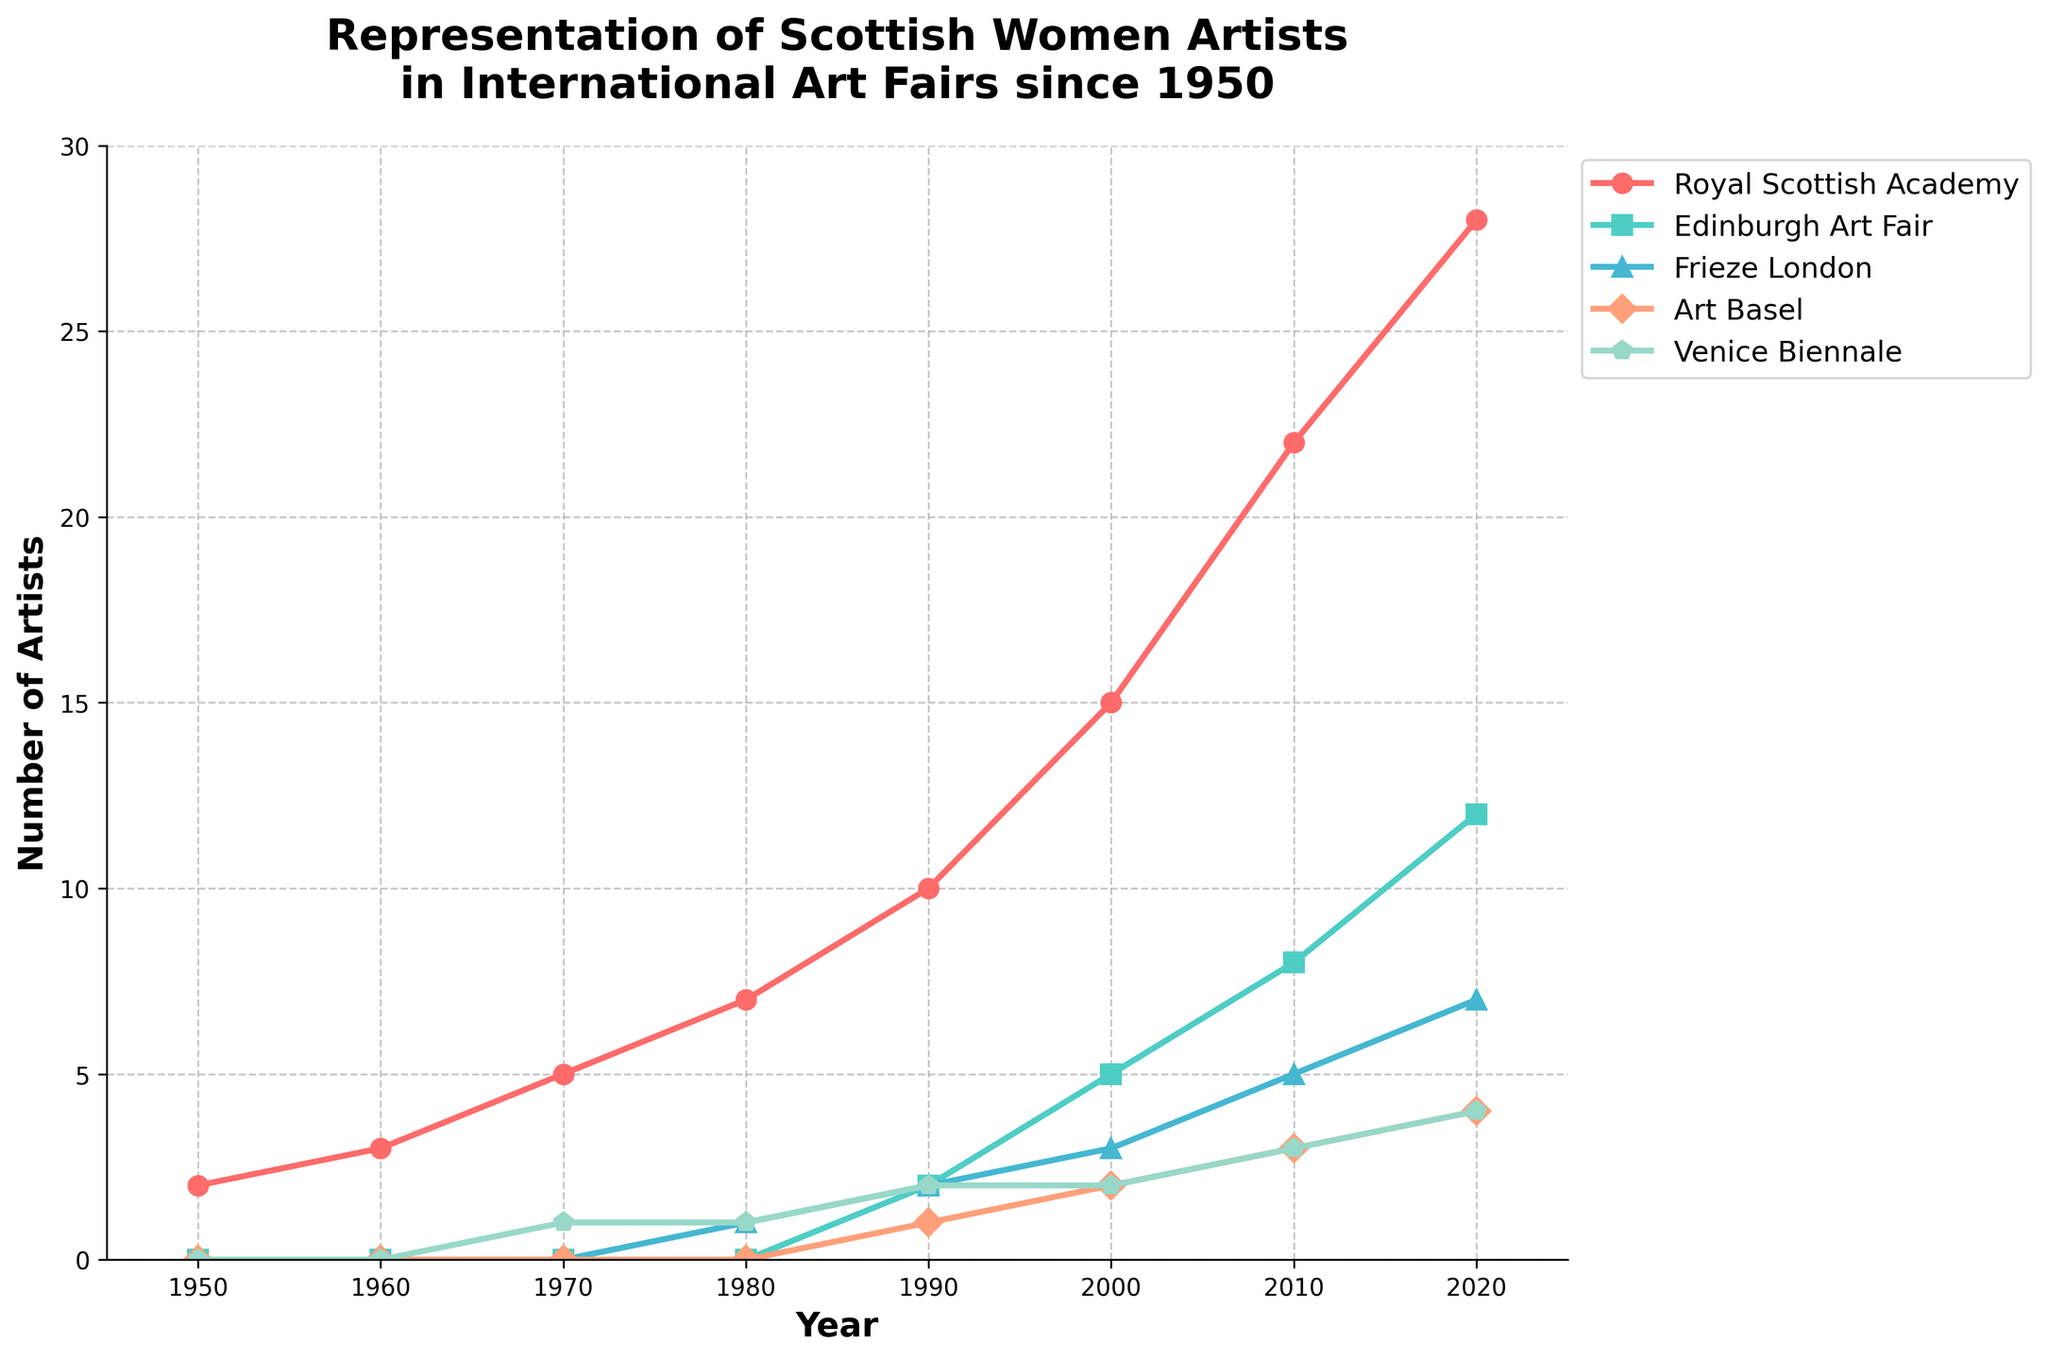Which year shows the highest representation of Scottish women artists in the Royal Scottish Academy? According to the chart, the representation in the Royal Scottish Academy increases over time. The highest represented year is 2020 with 28 artists.
Answer: 2020 How many artists in total were represented in all fairs in 1980? In 1980, the representation is: Royal Scottish Academy (7), Edinburgh Art Fair (0), Frieze London (1), Art Basel (0), Venice Biennale (1). Summing these gives 7 + 0 + 1 + 0 + 1 = 9.
Answer: 9 Between which two decades did the Royal Scottish Academy see the largest increase in representation? Comparing the individual increases: 1960-1950 (3-2=1), 1970-1960 (5-3=2), 1980-1970 (7-5=2), 1990-1980 (10-7=3), 2000-1990 (15-10=5), 2010-2000 (22-15=7), 2020-2010 (28-22=6), the largest increase occurred between 2000 and 2010 (7).
Answer: 2000-2010 Did Frieze London ever surpass Edinburgh Art Fair in representation during any of the years? Checking the chart, Edinburgh Art Fair consistently has higher representation numbers compared to Frieze London in all recorded years.
Answer: No Which art fair has the steepest growth in representation from 2010 to 2020? By comparing the slopes: Royal Scottish Academy (28-22=6), Edinburgh Art Fair (12-8=4), Frieze London (7-5=2), Art Basel (4-3=1), Venice Biennale (4-3=1). Edinburgh Art Fair has the highest growth with an increase of 4 artists.
Answer: Edinburgh Art Fair Which represents the blue line on the graph? The blue line corresponds to Frieze London as indicated in the legend of the chart.
Answer: Frieze London How many times did the representation of Scottish women artists in the Royal Scottish Academy double from 1950 to 2020? Doubling sequence is from 2 in 1950: 2x2=4 (achieved by 1970), 4x2=8 (before 1980), 8x2=16 (before 2010), 16x2=32 (not achieved). Thus it doubled three times.
Answer: 3 In which year did Venice Biennale first feature Scottish women artists? The chart shows Venice Biennale representing Scottish women artists starting in 1970.
Answer: 1970 